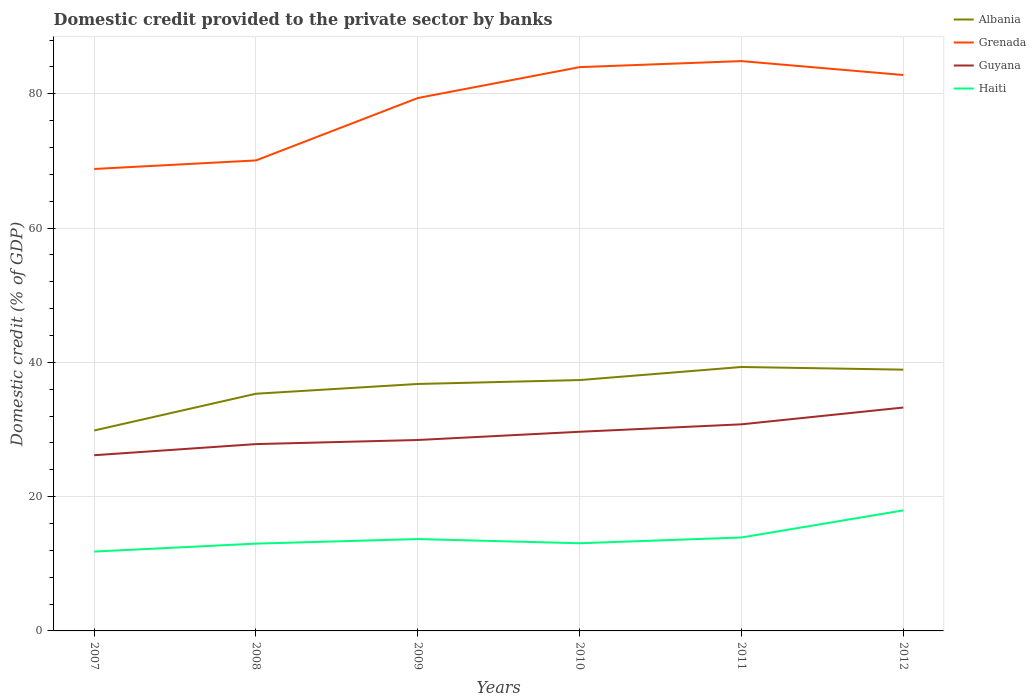Across all years, what is the maximum domestic credit provided to the private sector by banks in Grenada?
Offer a very short reply. 68.81. What is the total domestic credit provided to the private sector by banks in Haiti in the graph?
Your answer should be compact. -1.24. What is the difference between the highest and the second highest domestic credit provided to the private sector by banks in Grenada?
Your answer should be very brief. 16.07. Is the domestic credit provided to the private sector by banks in Albania strictly greater than the domestic credit provided to the private sector by banks in Haiti over the years?
Your response must be concise. No. Are the values on the major ticks of Y-axis written in scientific E-notation?
Keep it short and to the point. No. Does the graph contain any zero values?
Offer a very short reply. No. Does the graph contain grids?
Your answer should be very brief. Yes. Where does the legend appear in the graph?
Make the answer very short. Top right. How many legend labels are there?
Offer a very short reply. 4. How are the legend labels stacked?
Offer a terse response. Vertical. What is the title of the graph?
Ensure brevity in your answer.  Domestic credit provided to the private sector by banks. What is the label or title of the Y-axis?
Keep it short and to the point. Domestic credit (% of GDP). What is the Domestic credit (% of GDP) in Albania in 2007?
Offer a terse response. 29.86. What is the Domestic credit (% of GDP) of Grenada in 2007?
Your answer should be very brief. 68.81. What is the Domestic credit (% of GDP) in Guyana in 2007?
Your answer should be compact. 26.17. What is the Domestic credit (% of GDP) of Haiti in 2007?
Offer a very short reply. 11.82. What is the Domestic credit (% of GDP) of Albania in 2008?
Provide a short and direct response. 35.33. What is the Domestic credit (% of GDP) of Grenada in 2008?
Give a very brief answer. 70.08. What is the Domestic credit (% of GDP) of Guyana in 2008?
Your answer should be very brief. 27.83. What is the Domestic credit (% of GDP) in Haiti in 2008?
Keep it short and to the point. 13. What is the Domestic credit (% of GDP) in Albania in 2009?
Ensure brevity in your answer.  36.78. What is the Domestic credit (% of GDP) of Grenada in 2009?
Provide a short and direct response. 79.38. What is the Domestic credit (% of GDP) of Guyana in 2009?
Provide a succinct answer. 28.44. What is the Domestic credit (% of GDP) in Haiti in 2009?
Keep it short and to the point. 13.68. What is the Domestic credit (% of GDP) of Albania in 2010?
Offer a very short reply. 37.37. What is the Domestic credit (% of GDP) of Grenada in 2010?
Offer a terse response. 83.98. What is the Domestic credit (% of GDP) in Guyana in 2010?
Offer a very short reply. 29.66. What is the Domestic credit (% of GDP) in Haiti in 2010?
Provide a succinct answer. 13.06. What is the Domestic credit (% of GDP) in Albania in 2011?
Give a very brief answer. 39.31. What is the Domestic credit (% of GDP) in Grenada in 2011?
Offer a very short reply. 84.88. What is the Domestic credit (% of GDP) of Guyana in 2011?
Your answer should be very brief. 30.77. What is the Domestic credit (% of GDP) of Haiti in 2011?
Offer a very short reply. 13.92. What is the Domestic credit (% of GDP) of Albania in 2012?
Provide a short and direct response. 38.92. What is the Domestic credit (% of GDP) of Grenada in 2012?
Keep it short and to the point. 82.8. What is the Domestic credit (% of GDP) of Guyana in 2012?
Make the answer very short. 33.28. What is the Domestic credit (% of GDP) of Haiti in 2012?
Your answer should be compact. 17.95. Across all years, what is the maximum Domestic credit (% of GDP) of Albania?
Your response must be concise. 39.31. Across all years, what is the maximum Domestic credit (% of GDP) of Grenada?
Offer a very short reply. 84.88. Across all years, what is the maximum Domestic credit (% of GDP) in Guyana?
Ensure brevity in your answer.  33.28. Across all years, what is the maximum Domestic credit (% of GDP) in Haiti?
Provide a succinct answer. 17.95. Across all years, what is the minimum Domestic credit (% of GDP) of Albania?
Provide a short and direct response. 29.86. Across all years, what is the minimum Domestic credit (% of GDP) of Grenada?
Give a very brief answer. 68.81. Across all years, what is the minimum Domestic credit (% of GDP) of Guyana?
Provide a succinct answer. 26.17. Across all years, what is the minimum Domestic credit (% of GDP) in Haiti?
Your answer should be very brief. 11.82. What is the total Domestic credit (% of GDP) in Albania in the graph?
Provide a short and direct response. 217.57. What is the total Domestic credit (% of GDP) of Grenada in the graph?
Make the answer very short. 469.93. What is the total Domestic credit (% of GDP) of Guyana in the graph?
Make the answer very short. 176.15. What is the total Domestic credit (% of GDP) in Haiti in the graph?
Keep it short and to the point. 83.44. What is the difference between the Domestic credit (% of GDP) in Albania in 2007 and that in 2008?
Provide a succinct answer. -5.48. What is the difference between the Domestic credit (% of GDP) of Grenada in 2007 and that in 2008?
Your response must be concise. -1.27. What is the difference between the Domestic credit (% of GDP) in Guyana in 2007 and that in 2008?
Give a very brief answer. -1.66. What is the difference between the Domestic credit (% of GDP) of Haiti in 2007 and that in 2008?
Your response must be concise. -1.18. What is the difference between the Domestic credit (% of GDP) of Albania in 2007 and that in 2009?
Make the answer very short. -6.93. What is the difference between the Domestic credit (% of GDP) of Grenada in 2007 and that in 2009?
Offer a terse response. -10.57. What is the difference between the Domestic credit (% of GDP) of Guyana in 2007 and that in 2009?
Keep it short and to the point. -2.27. What is the difference between the Domestic credit (% of GDP) of Haiti in 2007 and that in 2009?
Offer a very short reply. -1.86. What is the difference between the Domestic credit (% of GDP) of Albania in 2007 and that in 2010?
Ensure brevity in your answer.  -7.51. What is the difference between the Domestic credit (% of GDP) in Grenada in 2007 and that in 2010?
Offer a terse response. -15.17. What is the difference between the Domestic credit (% of GDP) in Guyana in 2007 and that in 2010?
Ensure brevity in your answer.  -3.49. What is the difference between the Domestic credit (% of GDP) in Haiti in 2007 and that in 2010?
Offer a very short reply. -1.24. What is the difference between the Domestic credit (% of GDP) in Albania in 2007 and that in 2011?
Provide a succinct answer. -9.46. What is the difference between the Domestic credit (% of GDP) in Grenada in 2007 and that in 2011?
Make the answer very short. -16.07. What is the difference between the Domestic credit (% of GDP) of Guyana in 2007 and that in 2011?
Keep it short and to the point. -4.6. What is the difference between the Domestic credit (% of GDP) of Haiti in 2007 and that in 2011?
Provide a succinct answer. -2.1. What is the difference between the Domestic credit (% of GDP) of Albania in 2007 and that in 2012?
Keep it short and to the point. -9.06. What is the difference between the Domestic credit (% of GDP) in Grenada in 2007 and that in 2012?
Provide a short and direct response. -14. What is the difference between the Domestic credit (% of GDP) in Guyana in 2007 and that in 2012?
Make the answer very short. -7.1. What is the difference between the Domestic credit (% of GDP) in Haiti in 2007 and that in 2012?
Offer a terse response. -6.14. What is the difference between the Domestic credit (% of GDP) in Albania in 2008 and that in 2009?
Make the answer very short. -1.45. What is the difference between the Domestic credit (% of GDP) of Grenada in 2008 and that in 2009?
Give a very brief answer. -9.3. What is the difference between the Domestic credit (% of GDP) of Guyana in 2008 and that in 2009?
Your response must be concise. -0.61. What is the difference between the Domestic credit (% of GDP) of Haiti in 2008 and that in 2009?
Make the answer very short. -0.68. What is the difference between the Domestic credit (% of GDP) of Albania in 2008 and that in 2010?
Provide a short and direct response. -2.03. What is the difference between the Domestic credit (% of GDP) in Grenada in 2008 and that in 2010?
Offer a terse response. -13.9. What is the difference between the Domestic credit (% of GDP) in Guyana in 2008 and that in 2010?
Provide a short and direct response. -1.84. What is the difference between the Domestic credit (% of GDP) of Haiti in 2008 and that in 2010?
Your answer should be compact. -0.06. What is the difference between the Domestic credit (% of GDP) in Albania in 2008 and that in 2011?
Your answer should be compact. -3.98. What is the difference between the Domestic credit (% of GDP) in Grenada in 2008 and that in 2011?
Provide a succinct answer. -14.8. What is the difference between the Domestic credit (% of GDP) in Guyana in 2008 and that in 2011?
Your response must be concise. -2.95. What is the difference between the Domestic credit (% of GDP) in Haiti in 2008 and that in 2011?
Provide a short and direct response. -0.92. What is the difference between the Domestic credit (% of GDP) of Albania in 2008 and that in 2012?
Ensure brevity in your answer.  -3.59. What is the difference between the Domestic credit (% of GDP) in Grenada in 2008 and that in 2012?
Make the answer very short. -12.72. What is the difference between the Domestic credit (% of GDP) in Guyana in 2008 and that in 2012?
Provide a short and direct response. -5.45. What is the difference between the Domestic credit (% of GDP) of Haiti in 2008 and that in 2012?
Your response must be concise. -4.95. What is the difference between the Domestic credit (% of GDP) of Albania in 2009 and that in 2010?
Provide a short and direct response. -0.58. What is the difference between the Domestic credit (% of GDP) in Grenada in 2009 and that in 2010?
Provide a short and direct response. -4.6. What is the difference between the Domestic credit (% of GDP) of Guyana in 2009 and that in 2010?
Your answer should be very brief. -1.23. What is the difference between the Domestic credit (% of GDP) of Haiti in 2009 and that in 2010?
Make the answer very short. 0.62. What is the difference between the Domestic credit (% of GDP) in Albania in 2009 and that in 2011?
Make the answer very short. -2.53. What is the difference between the Domestic credit (% of GDP) of Grenada in 2009 and that in 2011?
Your response must be concise. -5.5. What is the difference between the Domestic credit (% of GDP) of Guyana in 2009 and that in 2011?
Ensure brevity in your answer.  -2.33. What is the difference between the Domestic credit (% of GDP) in Haiti in 2009 and that in 2011?
Make the answer very short. -0.24. What is the difference between the Domestic credit (% of GDP) in Albania in 2009 and that in 2012?
Keep it short and to the point. -2.13. What is the difference between the Domestic credit (% of GDP) in Grenada in 2009 and that in 2012?
Provide a succinct answer. -3.43. What is the difference between the Domestic credit (% of GDP) in Guyana in 2009 and that in 2012?
Offer a terse response. -4.84. What is the difference between the Domestic credit (% of GDP) in Haiti in 2009 and that in 2012?
Provide a short and direct response. -4.27. What is the difference between the Domestic credit (% of GDP) of Albania in 2010 and that in 2011?
Your answer should be very brief. -1.95. What is the difference between the Domestic credit (% of GDP) in Grenada in 2010 and that in 2011?
Your response must be concise. -0.9. What is the difference between the Domestic credit (% of GDP) of Guyana in 2010 and that in 2011?
Provide a succinct answer. -1.11. What is the difference between the Domestic credit (% of GDP) of Haiti in 2010 and that in 2011?
Ensure brevity in your answer.  -0.86. What is the difference between the Domestic credit (% of GDP) in Albania in 2010 and that in 2012?
Offer a terse response. -1.55. What is the difference between the Domestic credit (% of GDP) in Grenada in 2010 and that in 2012?
Provide a succinct answer. 1.18. What is the difference between the Domestic credit (% of GDP) of Guyana in 2010 and that in 2012?
Keep it short and to the point. -3.61. What is the difference between the Domestic credit (% of GDP) in Haiti in 2010 and that in 2012?
Offer a terse response. -4.9. What is the difference between the Domestic credit (% of GDP) in Albania in 2011 and that in 2012?
Offer a terse response. 0.4. What is the difference between the Domestic credit (% of GDP) in Grenada in 2011 and that in 2012?
Offer a terse response. 2.07. What is the difference between the Domestic credit (% of GDP) in Guyana in 2011 and that in 2012?
Offer a very short reply. -2.5. What is the difference between the Domestic credit (% of GDP) of Haiti in 2011 and that in 2012?
Your answer should be very brief. -4.03. What is the difference between the Domestic credit (% of GDP) in Albania in 2007 and the Domestic credit (% of GDP) in Grenada in 2008?
Provide a short and direct response. -40.23. What is the difference between the Domestic credit (% of GDP) of Albania in 2007 and the Domestic credit (% of GDP) of Guyana in 2008?
Ensure brevity in your answer.  2.03. What is the difference between the Domestic credit (% of GDP) in Albania in 2007 and the Domestic credit (% of GDP) in Haiti in 2008?
Offer a very short reply. 16.85. What is the difference between the Domestic credit (% of GDP) of Grenada in 2007 and the Domestic credit (% of GDP) of Guyana in 2008?
Provide a succinct answer. 40.98. What is the difference between the Domestic credit (% of GDP) of Grenada in 2007 and the Domestic credit (% of GDP) of Haiti in 2008?
Provide a short and direct response. 55.81. What is the difference between the Domestic credit (% of GDP) of Guyana in 2007 and the Domestic credit (% of GDP) of Haiti in 2008?
Offer a terse response. 13.17. What is the difference between the Domestic credit (% of GDP) in Albania in 2007 and the Domestic credit (% of GDP) in Grenada in 2009?
Keep it short and to the point. -49.52. What is the difference between the Domestic credit (% of GDP) of Albania in 2007 and the Domestic credit (% of GDP) of Guyana in 2009?
Make the answer very short. 1.42. What is the difference between the Domestic credit (% of GDP) of Albania in 2007 and the Domestic credit (% of GDP) of Haiti in 2009?
Offer a very short reply. 16.17. What is the difference between the Domestic credit (% of GDP) in Grenada in 2007 and the Domestic credit (% of GDP) in Guyana in 2009?
Make the answer very short. 40.37. What is the difference between the Domestic credit (% of GDP) of Grenada in 2007 and the Domestic credit (% of GDP) of Haiti in 2009?
Offer a terse response. 55.13. What is the difference between the Domestic credit (% of GDP) of Guyana in 2007 and the Domestic credit (% of GDP) of Haiti in 2009?
Offer a terse response. 12.49. What is the difference between the Domestic credit (% of GDP) of Albania in 2007 and the Domestic credit (% of GDP) of Grenada in 2010?
Provide a succinct answer. -54.12. What is the difference between the Domestic credit (% of GDP) in Albania in 2007 and the Domestic credit (% of GDP) in Guyana in 2010?
Ensure brevity in your answer.  0.19. What is the difference between the Domestic credit (% of GDP) of Albania in 2007 and the Domestic credit (% of GDP) of Haiti in 2010?
Ensure brevity in your answer.  16.8. What is the difference between the Domestic credit (% of GDP) of Grenada in 2007 and the Domestic credit (% of GDP) of Guyana in 2010?
Provide a short and direct response. 39.14. What is the difference between the Domestic credit (% of GDP) in Grenada in 2007 and the Domestic credit (% of GDP) in Haiti in 2010?
Offer a terse response. 55.75. What is the difference between the Domestic credit (% of GDP) in Guyana in 2007 and the Domestic credit (% of GDP) in Haiti in 2010?
Your answer should be compact. 13.11. What is the difference between the Domestic credit (% of GDP) in Albania in 2007 and the Domestic credit (% of GDP) in Grenada in 2011?
Your answer should be very brief. -55.02. What is the difference between the Domestic credit (% of GDP) in Albania in 2007 and the Domestic credit (% of GDP) in Guyana in 2011?
Ensure brevity in your answer.  -0.92. What is the difference between the Domestic credit (% of GDP) of Albania in 2007 and the Domestic credit (% of GDP) of Haiti in 2011?
Offer a very short reply. 15.93. What is the difference between the Domestic credit (% of GDP) of Grenada in 2007 and the Domestic credit (% of GDP) of Guyana in 2011?
Your response must be concise. 38.03. What is the difference between the Domestic credit (% of GDP) in Grenada in 2007 and the Domestic credit (% of GDP) in Haiti in 2011?
Offer a terse response. 54.89. What is the difference between the Domestic credit (% of GDP) of Guyana in 2007 and the Domestic credit (% of GDP) of Haiti in 2011?
Your answer should be very brief. 12.25. What is the difference between the Domestic credit (% of GDP) in Albania in 2007 and the Domestic credit (% of GDP) in Grenada in 2012?
Offer a very short reply. -52.95. What is the difference between the Domestic credit (% of GDP) in Albania in 2007 and the Domestic credit (% of GDP) in Guyana in 2012?
Make the answer very short. -3.42. What is the difference between the Domestic credit (% of GDP) in Albania in 2007 and the Domestic credit (% of GDP) in Haiti in 2012?
Offer a very short reply. 11.9. What is the difference between the Domestic credit (% of GDP) of Grenada in 2007 and the Domestic credit (% of GDP) of Guyana in 2012?
Your answer should be compact. 35.53. What is the difference between the Domestic credit (% of GDP) of Grenada in 2007 and the Domestic credit (% of GDP) of Haiti in 2012?
Keep it short and to the point. 50.85. What is the difference between the Domestic credit (% of GDP) of Guyana in 2007 and the Domestic credit (% of GDP) of Haiti in 2012?
Offer a very short reply. 8.22. What is the difference between the Domestic credit (% of GDP) in Albania in 2008 and the Domestic credit (% of GDP) in Grenada in 2009?
Offer a terse response. -44.05. What is the difference between the Domestic credit (% of GDP) in Albania in 2008 and the Domestic credit (% of GDP) in Guyana in 2009?
Your answer should be compact. 6.89. What is the difference between the Domestic credit (% of GDP) in Albania in 2008 and the Domestic credit (% of GDP) in Haiti in 2009?
Give a very brief answer. 21.65. What is the difference between the Domestic credit (% of GDP) of Grenada in 2008 and the Domestic credit (% of GDP) of Guyana in 2009?
Make the answer very short. 41.64. What is the difference between the Domestic credit (% of GDP) in Grenada in 2008 and the Domestic credit (% of GDP) in Haiti in 2009?
Provide a succinct answer. 56.4. What is the difference between the Domestic credit (% of GDP) of Guyana in 2008 and the Domestic credit (% of GDP) of Haiti in 2009?
Offer a terse response. 14.15. What is the difference between the Domestic credit (% of GDP) in Albania in 2008 and the Domestic credit (% of GDP) in Grenada in 2010?
Your response must be concise. -48.65. What is the difference between the Domestic credit (% of GDP) of Albania in 2008 and the Domestic credit (% of GDP) of Guyana in 2010?
Ensure brevity in your answer.  5.67. What is the difference between the Domestic credit (% of GDP) in Albania in 2008 and the Domestic credit (% of GDP) in Haiti in 2010?
Offer a very short reply. 22.27. What is the difference between the Domestic credit (% of GDP) in Grenada in 2008 and the Domestic credit (% of GDP) in Guyana in 2010?
Your answer should be very brief. 40.42. What is the difference between the Domestic credit (% of GDP) of Grenada in 2008 and the Domestic credit (% of GDP) of Haiti in 2010?
Offer a terse response. 57.02. What is the difference between the Domestic credit (% of GDP) in Guyana in 2008 and the Domestic credit (% of GDP) in Haiti in 2010?
Make the answer very short. 14.77. What is the difference between the Domestic credit (% of GDP) of Albania in 2008 and the Domestic credit (% of GDP) of Grenada in 2011?
Your answer should be compact. -49.55. What is the difference between the Domestic credit (% of GDP) of Albania in 2008 and the Domestic credit (% of GDP) of Guyana in 2011?
Give a very brief answer. 4.56. What is the difference between the Domestic credit (% of GDP) of Albania in 2008 and the Domestic credit (% of GDP) of Haiti in 2011?
Offer a very short reply. 21.41. What is the difference between the Domestic credit (% of GDP) in Grenada in 2008 and the Domestic credit (% of GDP) in Guyana in 2011?
Offer a terse response. 39.31. What is the difference between the Domestic credit (% of GDP) in Grenada in 2008 and the Domestic credit (% of GDP) in Haiti in 2011?
Your response must be concise. 56.16. What is the difference between the Domestic credit (% of GDP) in Guyana in 2008 and the Domestic credit (% of GDP) in Haiti in 2011?
Offer a terse response. 13.91. What is the difference between the Domestic credit (% of GDP) in Albania in 2008 and the Domestic credit (% of GDP) in Grenada in 2012?
Ensure brevity in your answer.  -47.47. What is the difference between the Domestic credit (% of GDP) of Albania in 2008 and the Domestic credit (% of GDP) of Guyana in 2012?
Make the answer very short. 2.06. What is the difference between the Domestic credit (% of GDP) of Albania in 2008 and the Domestic credit (% of GDP) of Haiti in 2012?
Make the answer very short. 17.38. What is the difference between the Domestic credit (% of GDP) of Grenada in 2008 and the Domestic credit (% of GDP) of Guyana in 2012?
Ensure brevity in your answer.  36.81. What is the difference between the Domestic credit (% of GDP) in Grenada in 2008 and the Domestic credit (% of GDP) in Haiti in 2012?
Provide a succinct answer. 52.13. What is the difference between the Domestic credit (% of GDP) in Guyana in 2008 and the Domestic credit (% of GDP) in Haiti in 2012?
Your answer should be very brief. 9.87. What is the difference between the Domestic credit (% of GDP) in Albania in 2009 and the Domestic credit (% of GDP) in Grenada in 2010?
Make the answer very short. -47.2. What is the difference between the Domestic credit (% of GDP) of Albania in 2009 and the Domestic credit (% of GDP) of Guyana in 2010?
Ensure brevity in your answer.  7.12. What is the difference between the Domestic credit (% of GDP) in Albania in 2009 and the Domestic credit (% of GDP) in Haiti in 2010?
Your answer should be very brief. 23.73. What is the difference between the Domestic credit (% of GDP) in Grenada in 2009 and the Domestic credit (% of GDP) in Guyana in 2010?
Your answer should be compact. 49.71. What is the difference between the Domestic credit (% of GDP) of Grenada in 2009 and the Domestic credit (% of GDP) of Haiti in 2010?
Ensure brevity in your answer.  66.32. What is the difference between the Domestic credit (% of GDP) in Guyana in 2009 and the Domestic credit (% of GDP) in Haiti in 2010?
Ensure brevity in your answer.  15.38. What is the difference between the Domestic credit (% of GDP) in Albania in 2009 and the Domestic credit (% of GDP) in Grenada in 2011?
Your answer should be compact. -48.09. What is the difference between the Domestic credit (% of GDP) of Albania in 2009 and the Domestic credit (% of GDP) of Guyana in 2011?
Your answer should be compact. 6.01. What is the difference between the Domestic credit (% of GDP) of Albania in 2009 and the Domestic credit (% of GDP) of Haiti in 2011?
Your response must be concise. 22.86. What is the difference between the Domestic credit (% of GDP) in Grenada in 2009 and the Domestic credit (% of GDP) in Guyana in 2011?
Your answer should be compact. 48.6. What is the difference between the Domestic credit (% of GDP) of Grenada in 2009 and the Domestic credit (% of GDP) of Haiti in 2011?
Your answer should be very brief. 65.46. What is the difference between the Domestic credit (% of GDP) of Guyana in 2009 and the Domestic credit (% of GDP) of Haiti in 2011?
Make the answer very short. 14.52. What is the difference between the Domestic credit (% of GDP) in Albania in 2009 and the Domestic credit (% of GDP) in Grenada in 2012?
Your response must be concise. -46.02. What is the difference between the Domestic credit (% of GDP) of Albania in 2009 and the Domestic credit (% of GDP) of Guyana in 2012?
Your response must be concise. 3.51. What is the difference between the Domestic credit (% of GDP) of Albania in 2009 and the Domestic credit (% of GDP) of Haiti in 2012?
Your answer should be compact. 18.83. What is the difference between the Domestic credit (% of GDP) of Grenada in 2009 and the Domestic credit (% of GDP) of Guyana in 2012?
Give a very brief answer. 46.1. What is the difference between the Domestic credit (% of GDP) in Grenada in 2009 and the Domestic credit (% of GDP) in Haiti in 2012?
Your answer should be very brief. 61.42. What is the difference between the Domestic credit (% of GDP) in Guyana in 2009 and the Domestic credit (% of GDP) in Haiti in 2012?
Offer a terse response. 10.48. What is the difference between the Domestic credit (% of GDP) in Albania in 2010 and the Domestic credit (% of GDP) in Grenada in 2011?
Your response must be concise. -47.51. What is the difference between the Domestic credit (% of GDP) in Albania in 2010 and the Domestic credit (% of GDP) in Guyana in 2011?
Offer a very short reply. 6.59. What is the difference between the Domestic credit (% of GDP) in Albania in 2010 and the Domestic credit (% of GDP) in Haiti in 2011?
Give a very brief answer. 23.45. What is the difference between the Domestic credit (% of GDP) in Grenada in 2010 and the Domestic credit (% of GDP) in Guyana in 2011?
Offer a very short reply. 53.21. What is the difference between the Domestic credit (% of GDP) of Grenada in 2010 and the Domestic credit (% of GDP) of Haiti in 2011?
Provide a succinct answer. 70.06. What is the difference between the Domestic credit (% of GDP) of Guyana in 2010 and the Domestic credit (% of GDP) of Haiti in 2011?
Offer a very short reply. 15.74. What is the difference between the Domestic credit (% of GDP) of Albania in 2010 and the Domestic credit (% of GDP) of Grenada in 2012?
Give a very brief answer. -45.44. What is the difference between the Domestic credit (% of GDP) of Albania in 2010 and the Domestic credit (% of GDP) of Guyana in 2012?
Provide a succinct answer. 4.09. What is the difference between the Domestic credit (% of GDP) in Albania in 2010 and the Domestic credit (% of GDP) in Haiti in 2012?
Offer a terse response. 19.41. What is the difference between the Domestic credit (% of GDP) of Grenada in 2010 and the Domestic credit (% of GDP) of Guyana in 2012?
Your answer should be very brief. 50.7. What is the difference between the Domestic credit (% of GDP) in Grenada in 2010 and the Domestic credit (% of GDP) in Haiti in 2012?
Provide a short and direct response. 66.03. What is the difference between the Domestic credit (% of GDP) in Guyana in 2010 and the Domestic credit (% of GDP) in Haiti in 2012?
Your answer should be compact. 11.71. What is the difference between the Domestic credit (% of GDP) in Albania in 2011 and the Domestic credit (% of GDP) in Grenada in 2012?
Provide a succinct answer. -43.49. What is the difference between the Domestic credit (% of GDP) in Albania in 2011 and the Domestic credit (% of GDP) in Guyana in 2012?
Give a very brief answer. 6.04. What is the difference between the Domestic credit (% of GDP) of Albania in 2011 and the Domestic credit (% of GDP) of Haiti in 2012?
Give a very brief answer. 21.36. What is the difference between the Domestic credit (% of GDP) in Grenada in 2011 and the Domestic credit (% of GDP) in Guyana in 2012?
Your response must be concise. 51.6. What is the difference between the Domestic credit (% of GDP) in Grenada in 2011 and the Domestic credit (% of GDP) in Haiti in 2012?
Your answer should be very brief. 66.92. What is the difference between the Domestic credit (% of GDP) of Guyana in 2011 and the Domestic credit (% of GDP) of Haiti in 2012?
Provide a short and direct response. 12.82. What is the average Domestic credit (% of GDP) in Albania per year?
Offer a terse response. 36.26. What is the average Domestic credit (% of GDP) of Grenada per year?
Keep it short and to the point. 78.32. What is the average Domestic credit (% of GDP) in Guyana per year?
Give a very brief answer. 29.36. What is the average Domestic credit (% of GDP) of Haiti per year?
Offer a terse response. 13.91. In the year 2007, what is the difference between the Domestic credit (% of GDP) of Albania and Domestic credit (% of GDP) of Grenada?
Your answer should be very brief. -38.95. In the year 2007, what is the difference between the Domestic credit (% of GDP) of Albania and Domestic credit (% of GDP) of Guyana?
Ensure brevity in your answer.  3.68. In the year 2007, what is the difference between the Domestic credit (% of GDP) in Albania and Domestic credit (% of GDP) in Haiti?
Your answer should be very brief. 18.04. In the year 2007, what is the difference between the Domestic credit (% of GDP) of Grenada and Domestic credit (% of GDP) of Guyana?
Offer a terse response. 42.64. In the year 2007, what is the difference between the Domestic credit (% of GDP) of Grenada and Domestic credit (% of GDP) of Haiti?
Offer a terse response. 56.99. In the year 2007, what is the difference between the Domestic credit (% of GDP) of Guyana and Domestic credit (% of GDP) of Haiti?
Your answer should be very brief. 14.35. In the year 2008, what is the difference between the Domestic credit (% of GDP) of Albania and Domestic credit (% of GDP) of Grenada?
Offer a terse response. -34.75. In the year 2008, what is the difference between the Domestic credit (% of GDP) of Albania and Domestic credit (% of GDP) of Guyana?
Your answer should be very brief. 7.5. In the year 2008, what is the difference between the Domestic credit (% of GDP) in Albania and Domestic credit (% of GDP) in Haiti?
Offer a terse response. 22.33. In the year 2008, what is the difference between the Domestic credit (% of GDP) in Grenada and Domestic credit (% of GDP) in Guyana?
Offer a very short reply. 42.25. In the year 2008, what is the difference between the Domestic credit (% of GDP) in Grenada and Domestic credit (% of GDP) in Haiti?
Give a very brief answer. 57.08. In the year 2008, what is the difference between the Domestic credit (% of GDP) of Guyana and Domestic credit (% of GDP) of Haiti?
Ensure brevity in your answer.  14.83. In the year 2009, what is the difference between the Domestic credit (% of GDP) of Albania and Domestic credit (% of GDP) of Grenada?
Your answer should be very brief. -42.59. In the year 2009, what is the difference between the Domestic credit (% of GDP) in Albania and Domestic credit (% of GDP) in Guyana?
Provide a short and direct response. 8.35. In the year 2009, what is the difference between the Domestic credit (% of GDP) of Albania and Domestic credit (% of GDP) of Haiti?
Make the answer very short. 23.1. In the year 2009, what is the difference between the Domestic credit (% of GDP) of Grenada and Domestic credit (% of GDP) of Guyana?
Your answer should be very brief. 50.94. In the year 2009, what is the difference between the Domestic credit (% of GDP) in Grenada and Domestic credit (% of GDP) in Haiti?
Offer a very short reply. 65.69. In the year 2009, what is the difference between the Domestic credit (% of GDP) of Guyana and Domestic credit (% of GDP) of Haiti?
Offer a terse response. 14.76. In the year 2010, what is the difference between the Domestic credit (% of GDP) of Albania and Domestic credit (% of GDP) of Grenada?
Provide a short and direct response. -46.61. In the year 2010, what is the difference between the Domestic credit (% of GDP) in Albania and Domestic credit (% of GDP) in Guyana?
Ensure brevity in your answer.  7.7. In the year 2010, what is the difference between the Domestic credit (% of GDP) of Albania and Domestic credit (% of GDP) of Haiti?
Ensure brevity in your answer.  24.31. In the year 2010, what is the difference between the Domestic credit (% of GDP) of Grenada and Domestic credit (% of GDP) of Guyana?
Offer a very short reply. 54.31. In the year 2010, what is the difference between the Domestic credit (% of GDP) of Grenada and Domestic credit (% of GDP) of Haiti?
Your response must be concise. 70.92. In the year 2010, what is the difference between the Domestic credit (% of GDP) of Guyana and Domestic credit (% of GDP) of Haiti?
Keep it short and to the point. 16.61. In the year 2011, what is the difference between the Domestic credit (% of GDP) in Albania and Domestic credit (% of GDP) in Grenada?
Your response must be concise. -45.56. In the year 2011, what is the difference between the Domestic credit (% of GDP) in Albania and Domestic credit (% of GDP) in Guyana?
Offer a terse response. 8.54. In the year 2011, what is the difference between the Domestic credit (% of GDP) of Albania and Domestic credit (% of GDP) of Haiti?
Your answer should be compact. 25.39. In the year 2011, what is the difference between the Domestic credit (% of GDP) in Grenada and Domestic credit (% of GDP) in Guyana?
Provide a short and direct response. 54.1. In the year 2011, what is the difference between the Domestic credit (% of GDP) in Grenada and Domestic credit (% of GDP) in Haiti?
Your answer should be very brief. 70.96. In the year 2011, what is the difference between the Domestic credit (% of GDP) of Guyana and Domestic credit (% of GDP) of Haiti?
Offer a terse response. 16.85. In the year 2012, what is the difference between the Domestic credit (% of GDP) of Albania and Domestic credit (% of GDP) of Grenada?
Your answer should be compact. -43.89. In the year 2012, what is the difference between the Domestic credit (% of GDP) in Albania and Domestic credit (% of GDP) in Guyana?
Your answer should be very brief. 5.64. In the year 2012, what is the difference between the Domestic credit (% of GDP) of Albania and Domestic credit (% of GDP) of Haiti?
Your response must be concise. 20.96. In the year 2012, what is the difference between the Domestic credit (% of GDP) of Grenada and Domestic credit (% of GDP) of Guyana?
Offer a very short reply. 49.53. In the year 2012, what is the difference between the Domestic credit (% of GDP) in Grenada and Domestic credit (% of GDP) in Haiti?
Your response must be concise. 64.85. In the year 2012, what is the difference between the Domestic credit (% of GDP) in Guyana and Domestic credit (% of GDP) in Haiti?
Ensure brevity in your answer.  15.32. What is the ratio of the Domestic credit (% of GDP) of Albania in 2007 to that in 2008?
Give a very brief answer. 0.84. What is the ratio of the Domestic credit (% of GDP) in Grenada in 2007 to that in 2008?
Ensure brevity in your answer.  0.98. What is the ratio of the Domestic credit (% of GDP) in Guyana in 2007 to that in 2008?
Give a very brief answer. 0.94. What is the ratio of the Domestic credit (% of GDP) of Haiti in 2007 to that in 2008?
Your answer should be very brief. 0.91. What is the ratio of the Domestic credit (% of GDP) of Albania in 2007 to that in 2009?
Ensure brevity in your answer.  0.81. What is the ratio of the Domestic credit (% of GDP) of Grenada in 2007 to that in 2009?
Keep it short and to the point. 0.87. What is the ratio of the Domestic credit (% of GDP) of Guyana in 2007 to that in 2009?
Your answer should be compact. 0.92. What is the ratio of the Domestic credit (% of GDP) of Haiti in 2007 to that in 2009?
Make the answer very short. 0.86. What is the ratio of the Domestic credit (% of GDP) of Albania in 2007 to that in 2010?
Keep it short and to the point. 0.8. What is the ratio of the Domestic credit (% of GDP) in Grenada in 2007 to that in 2010?
Your answer should be very brief. 0.82. What is the ratio of the Domestic credit (% of GDP) in Guyana in 2007 to that in 2010?
Your answer should be very brief. 0.88. What is the ratio of the Domestic credit (% of GDP) of Haiti in 2007 to that in 2010?
Provide a short and direct response. 0.91. What is the ratio of the Domestic credit (% of GDP) in Albania in 2007 to that in 2011?
Make the answer very short. 0.76. What is the ratio of the Domestic credit (% of GDP) of Grenada in 2007 to that in 2011?
Offer a terse response. 0.81. What is the ratio of the Domestic credit (% of GDP) of Guyana in 2007 to that in 2011?
Ensure brevity in your answer.  0.85. What is the ratio of the Domestic credit (% of GDP) in Haiti in 2007 to that in 2011?
Your response must be concise. 0.85. What is the ratio of the Domestic credit (% of GDP) of Albania in 2007 to that in 2012?
Provide a succinct answer. 0.77. What is the ratio of the Domestic credit (% of GDP) in Grenada in 2007 to that in 2012?
Your answer should be compact. 0.83. What is the ratio of the Domestic credit (% of GDP) of Guyana in 2007 to that in 2012?
Your response must be concise. 0.79. What is the ratio of the Domestic credit (% of GDP) of Haiti in 2007 to that in 2012?
Make the answer very short. 0.66. What is the ratio of the Domestic credit (% of GDP) in Albania in 2008 to that in 2009?
Provide a short and direct response. 0.96. What is the ratio of the Domestic credit (% of GDP) of Grenada in 2008 to that in 2009?
Provide a succinct answer. 0.88. What is the ratio of the Domestic credit (% of GDP) in Guyana in 2008 to that in 2009?
Keep it short and to the point. 0.98. What is the ratio of the Domestic credit (% of GDP) in Haiti in 2008 to that in 2009?
Provide a succinct answer. 0.95. What is the ratio of the Domestic credit (% of GDP) in Albania in 2008 to that in 2010?
Ensure brevity in your answer.  0.95. What is the ratio of the Domestic credit (% of GDP) of Grenada in 2008 to that in 2010?
Your answer should be compact. 0.83. What is the ratio of the Domestic credit (% of GDP) of Guyana in 2008 to that in 2010?
Your response must be concise. 0.94. What is the ratio of the Domestic credit (% of GDP) in Albania in 2008 to that in 2011?
Your answer should be very brief. 0.9. What is the ratio of the Domestic credit (% of GDP) in Grenada in 2008 to that in 2011?
Provide a succinct answer. 0.83. What is the ratio of the Domestic credit (% of GDP) in Guyana in 2008 to that in 2011?
Your answer should be very brief. 0.9. What is the ratio of the Domestic credit (% of GDP) of Haiti in 2008 to that in 2011?
Offer a very short reply. 0.93. What is the ratio of the Domestic credit (% of GDP) in Albania in 2008 to that in 2012?
Provide a short and direct response. 0.91. What is the ratio of the Domestic credit (% of GDP) in Grenada in 2008 to that in 2012?
Your answer should be compact. 0.85. What is the ratio of the Domestic credit (% of GDP) in Guyana in 2008 to that in 2012?
Make the answer very short. 0.84. What is the ratio of the Domestic credit (% of GDP) in Haiti in 2008 to that in 2012?
Provide a succinct answer. 0.72. What is the ratio of the Domestic credit (% of GDP) in Albania in 2009 to that in 2010?
Keep it short and to the point. 0.98. What is the ratio of the Domestic credit (% of GDP) of Grenada in 2009 to that in 2010?
Give a very brief answer. 0.95. What is the ratio of the Domestic credit (% of GDP) of Guyana in 2009 to that in 2010?
Offer a terse response. 0.96. What is the ratio of the Domestic credit (% of GDP) in Haiti in 2009 to that in 2010?
Your answer should be very brief. 1.05. What is the ratio of the Domestic credit (% of GDP) in Albania in 2009 to that in 2011?
Give a very brief answer. 0.94. What is the ratio of the Domestic credit (% of GDP) of Grenada in 2009 to that in 2011?
Ensure brevity in your answer.  0.94. What is the ratio of the Domestic credit (% of GDP) in Guyana in 2009 to that in 2011?
Keep it short and to the point. 0.92. What is the ratio of the Domestic credit (% of GDP) in Haiti in 2009 to that in 2011?
Offer a terse response. 0.98. What is the ratio of the Domestic credit (% of GDP) of Albania in 2009 to that in 2012?
Provide a succinct answer. 0.95. What is the ratio of the Domestic credit (% of GDP) of Grenada in 2009 to that in 2012?
Give a very brief answer. 0.96. What is the ratio of the Domestic credit (% of GDP) in Guyana in 2009 to that in 2012?
Offer a very short reply. 0.85. What is the ratio of the Domestic credit (% of GDP) in Haiti in 2009 to that in 2012?
Your answer should be very brief. 0.76. What is the ratio of the Domestic credit (% of GDP) of Albania in 2010 to that in 2011?
Keep it short and to the point. 0.95. What is the ratio of the Domestic credit (% of GDP) in Guyana in 2010 to that in 2011?
Make the answer very short. 0.96. What is the ratio of the Domestic credit (% of GDP) in Haiti in 2010 to that in 2011?
Make the answer very short. 0.94. What is the ratio of the Domestic credit (% of GDP) of Albania in 2010 to that in 2012?
Make the answer very short. 0.96. What is the ratio of the Domestic credit (% of GDP) in Grenada in 2010 to that in 2012?
Your answer should be very brief. 1.01. What is the ratio of the Domestic credit (% of GDP) of Guyana in 2010 to that in 2012?
Your answer should be compact. 0.89. What is the ratio of the Domestic credit (% of GDP) in Haiti in 2010 to that in 2012?
Keep it short and to the point. 0.73. What is the ratio of the Domestic credit (% of GDP) of Albania in 2011 to that in 2012?
Ensure brevity in your answer.  1.01. What is the ratio of the Domestic credit (% of GDP) in Guyana in 2011 to that in 2012?
Make the answer very short. 0.92. What is the ratio of the Domestic credit (% of GDP) of Haiti in 2011 to that in 2012?
Give a very brief answer. 0.78. What is the difference between the highest and the second highest Domestic credit (% of GDP) of Albania?
Your response must be concise. 0.4. What is the difference between the highest and the second highest Domestic credit (% of GDP) in Grenada?
Provide a short and direct response. 0.9. What is the difference between the highest and the second highest Domestic credit (% of GDP) of Guyana?
Your response must be concise. 2.5. What is the difference between the highest and the second highest Domestic credit (% of GDP) of Haiti?
Keep it short and to the point. 4.03. What is the difference between the highest and the lowest Domestic credit (% of GDP) in Albania?
Your answer should be very brief. 9.46. What is the difference between the highest and the lowest Domestic credit (% of GDP) of Grenada?
Ensure brevity in your answer.  16.07. What is the difference between the highest and the lowest Domestic credit (% of GDP) of Guyana?
Make the answer very short. 7.1. What is the difference between the highest and the lowest Domestic credit (% of GDP) in Haiti?
Make the answer very short. 6.14. 